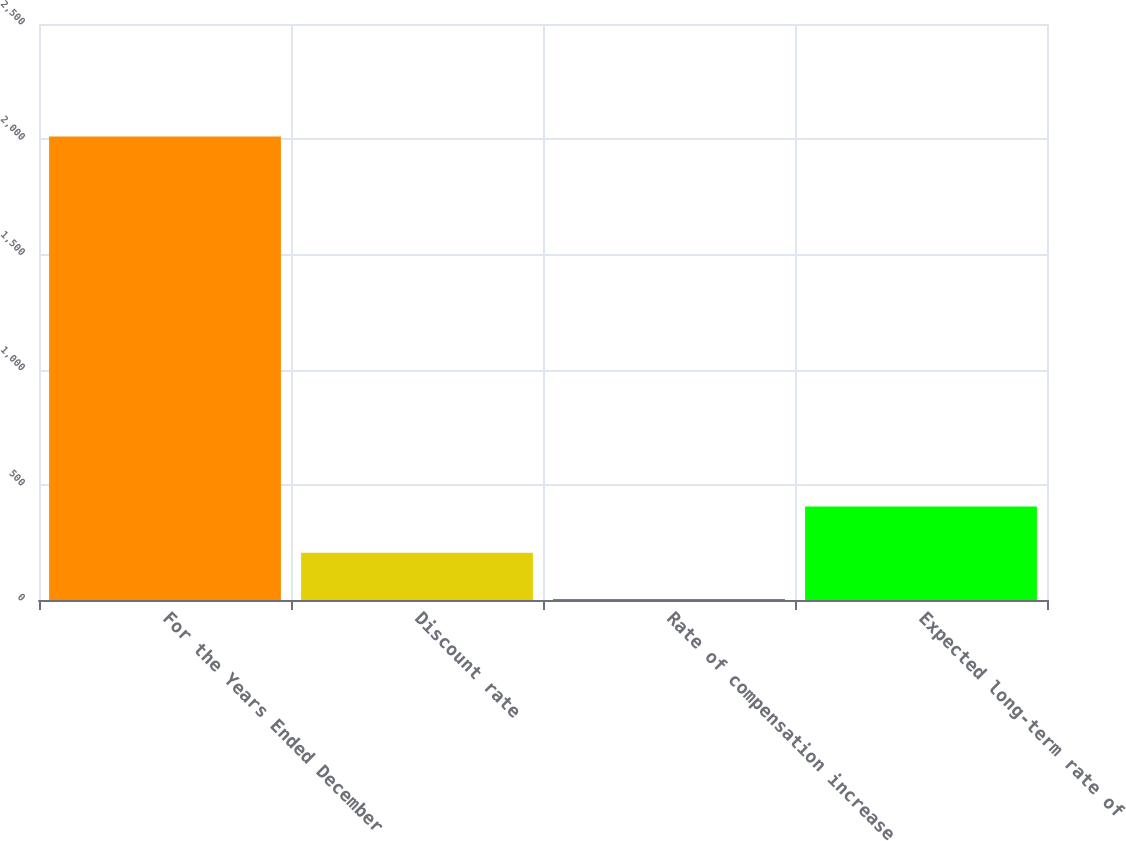Convert chart. <chart><loc_0><loc_0><loc_500><loc_500><bar_chart><fcel>For the Years Ended December<fcel>Discount rate<fcel>Rate of compensation increase<fcel>Expected long-term rate of<nl><fcel>2012<fcel>204.63<fcel>3.81<fcel>405.45<nl></chart> 